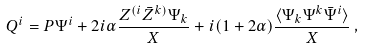Convert formula to latex. <formula><loc_0><loc_0><loc_500><loc_500>Q ^ { i } = P \Psi ^ { i } + 2 i \alpha \frac { Z ^ { ( i } \bar { Z } ^ { k ) } \Psi _ { k } } { X } + i ( 1 + 2 \alpha ) \frac { \langle \Psi _ { k } \Psi ^ { k } \bar { \Psi } ^ { i } \rangle } { X } \, ,</formula> 